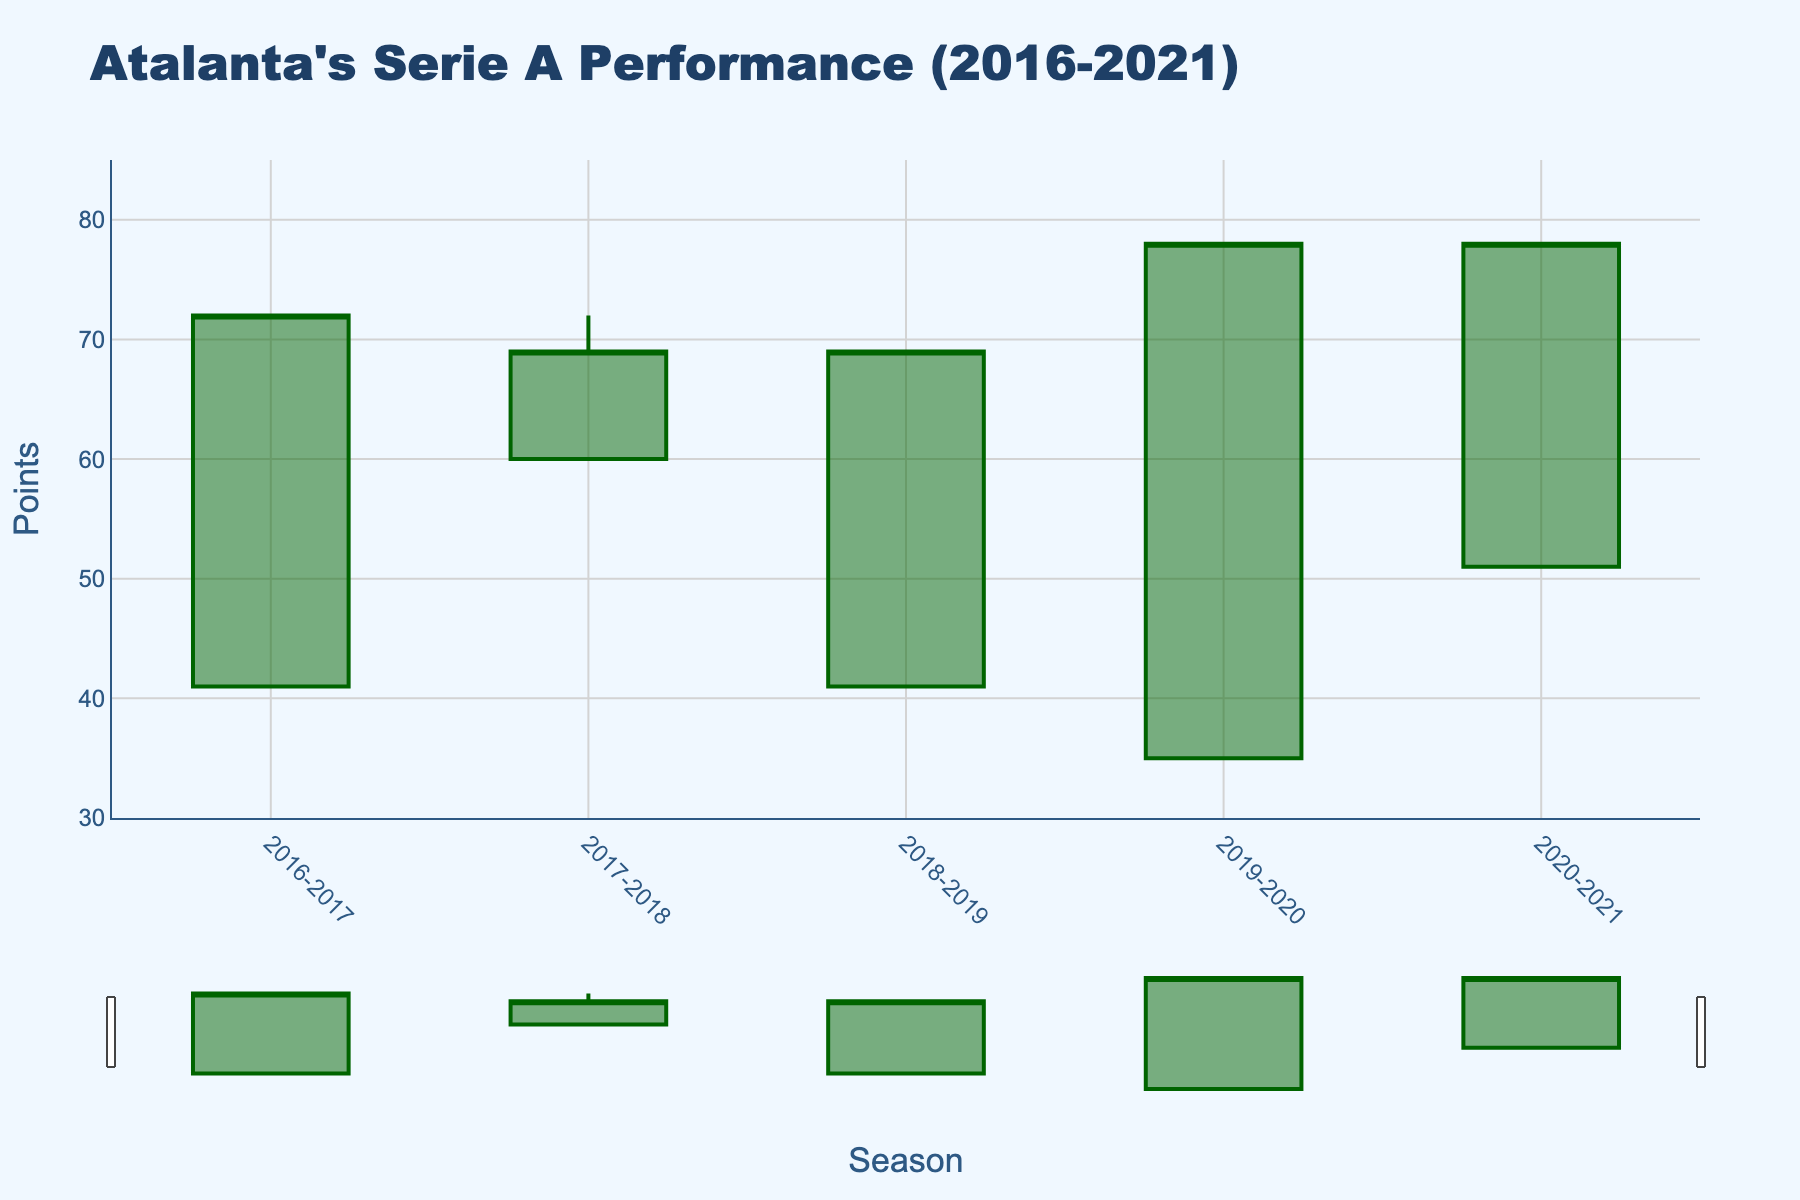what is the highest point achieved by Atalanta in the 2019-2020 season? The high value represents the highest point. In the plot, the highest point for 2019-2020 is 78, displayed as the high value.
Answer: 78 Between which seasons did Atalanta's points not change? The close value represents the final points. By comparing the close values, 2019-2020 and 2020-2021 both have 78 points.
Answer: 2019-2020 and 2020-2021 What is the average of the opening points across all seasons? Adding all opening points together and then dividing by the number of seasons: (41 + 60 + 41 + 35 + 51) / 5 = 45.6
Answer: 45.6 Which season had the widest range between the highest and lowest points? Subtracting the low value from the high value for each season. The greatest difference is for 2019-2020 and 2020-2021 both having a range of 43 points (78 - 35 and 78 - 51).
Answer: 2019-2020 and 2020-2021 Did Atalanta's points increase or decrease more frequently within a season? Observing the direction of the candlestick shadows: Increasing occurs if the close is higher than the open; otherwise, it decreases. Both 2016-2017, 2019-2020, and 2020-2021 have increasing points. 2017-2018 and 2018-2019 have decreasing points. Increase more frequently due to three increasing seasons against two decreasing seasons.
Answer: Increased During which season did Atalanta start and end with the same number of points? Analyzing the candlestick where open equals close value. Both 2016-2017 and 2018-2019 show no changes between the open and close values.
Answer: 2016-2017 and 2018-2019 Which season had the smallest difference between opened and closed points? Subtracting open from close in absolute terms to find the minimum difference. 2017-2018 shows the smallest difference at 9 points (69 - 60).
Answer: 2017-2018 